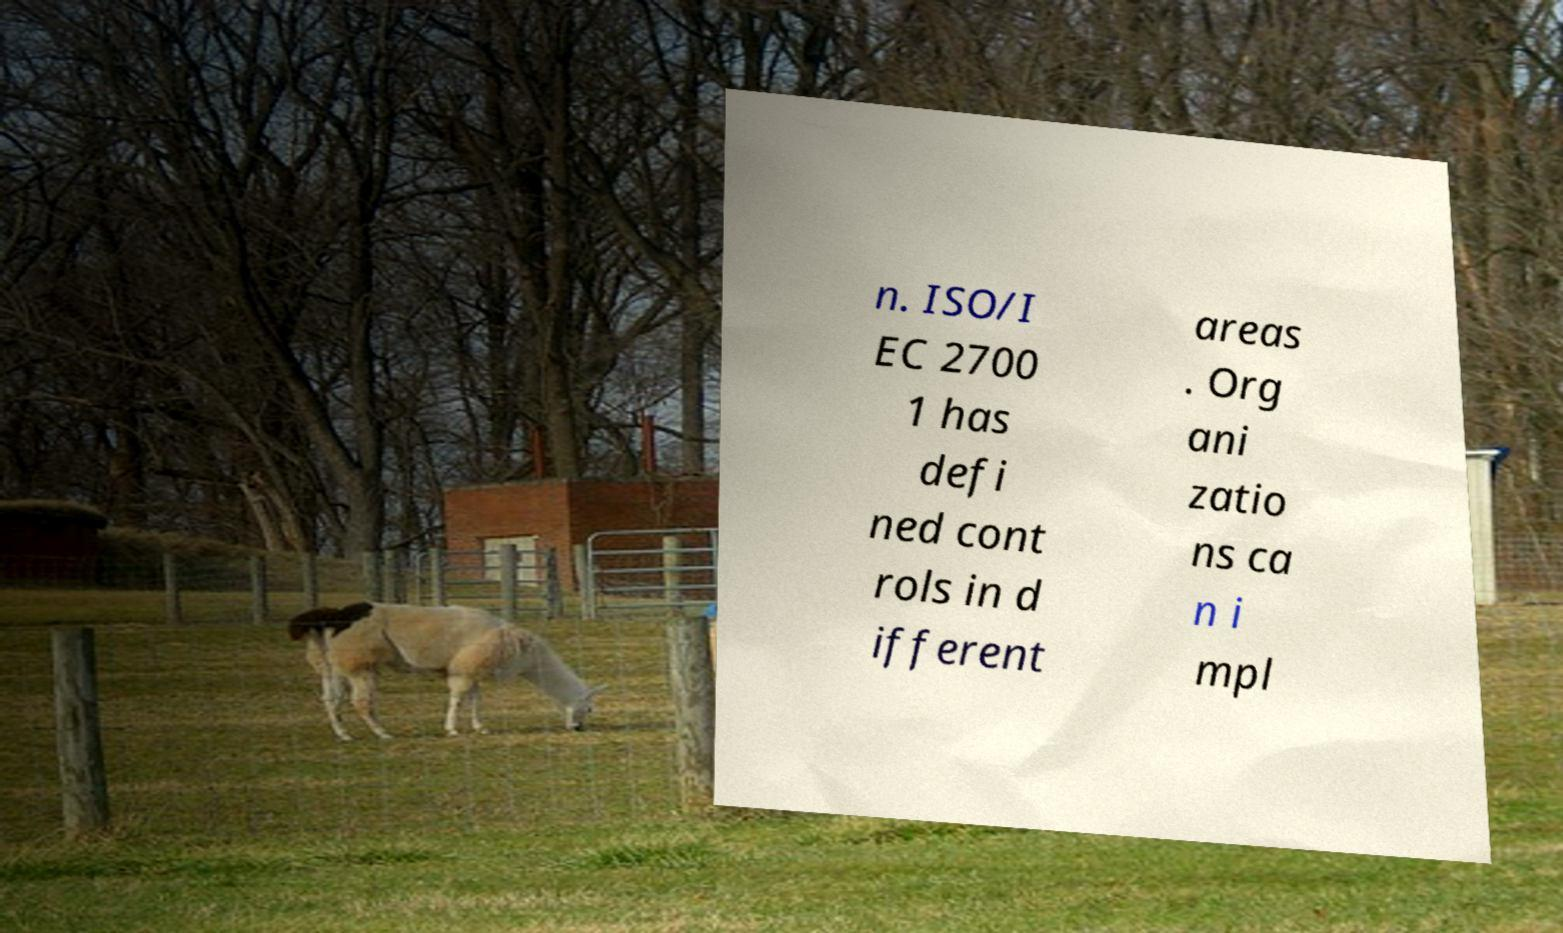For documentation purposes, I need the text within this image transcribed. Could you provide that? n. ISO/I EC 2700 1 has defi ned cont rols in d ifferent areas . Org ani zatio ns ca n i mpl 